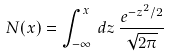Convert formula to latex. <formula><loc_0><loc_0><loc_500><loc_500>N ( x ) = \int _ { - \infty } ^ { x } \, d z \, \frac { e ^ { - z ^ { 2 } / 2 } } { \sqrt { 2 \pi } }</formula> 